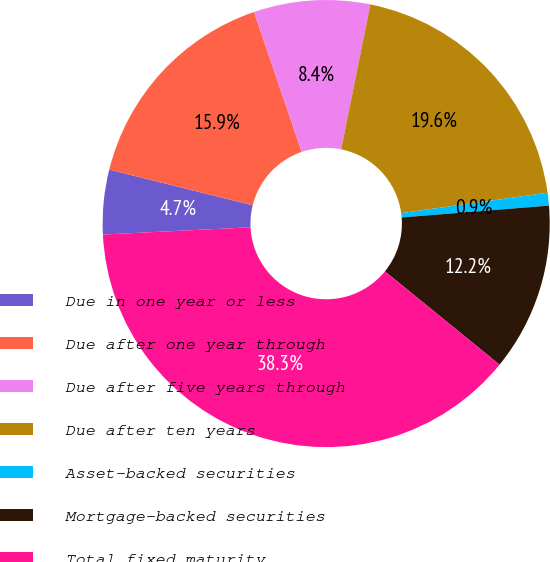<chart> <loc_0><loc_0><loc_500><loc_500><pie_chart><fcel>Due in one year or less<fcel>Due after one year through<fcel>Due after five years through<fcel>Due after ten years<fcel>Asset-backed securities<fcel>Mortgage-backed securities<fcel>Total fixed maturity<nl><fcel>4.66%<fcel>15.89%<fcel>8.4%<fcel>19.63%<fcel>0.92%<fcel>12.15%<fcel>38.34%<nl></chart> 